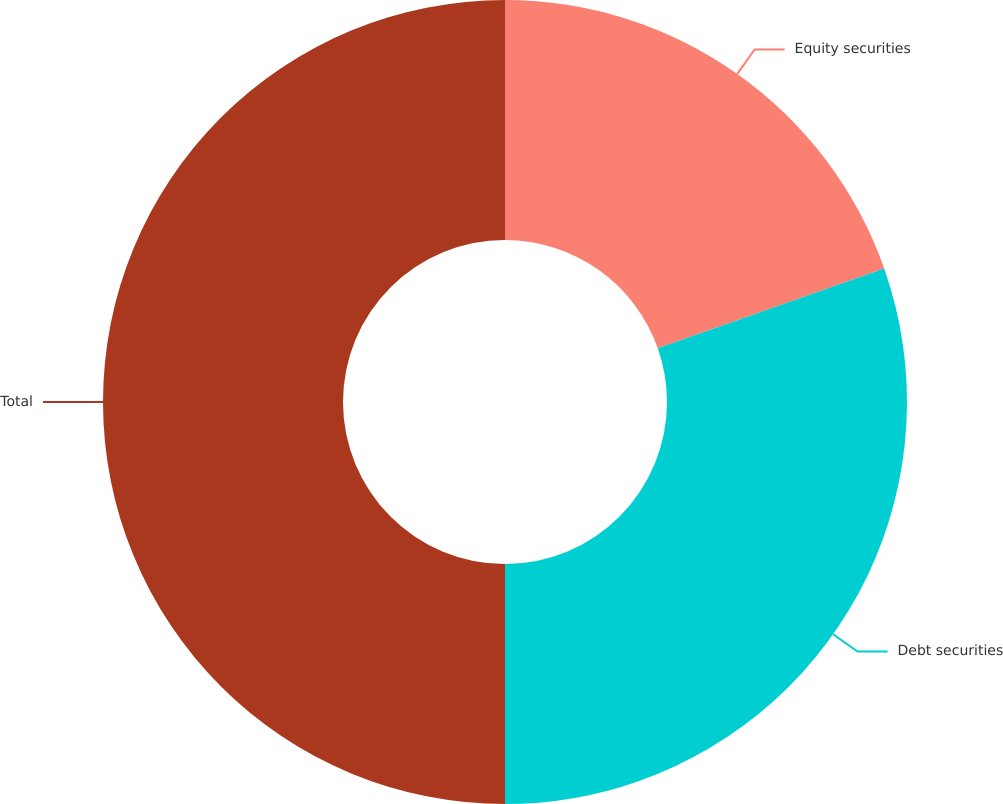<chart> <loc_0><loc_0><loc_500><loc_500><pie_chart><fcel>Equity securities<fcel>Debt securities<fcel>Total<nl><fcel>19.61%<fcel>30.39%<fcel>50.0%<nl></chart> 